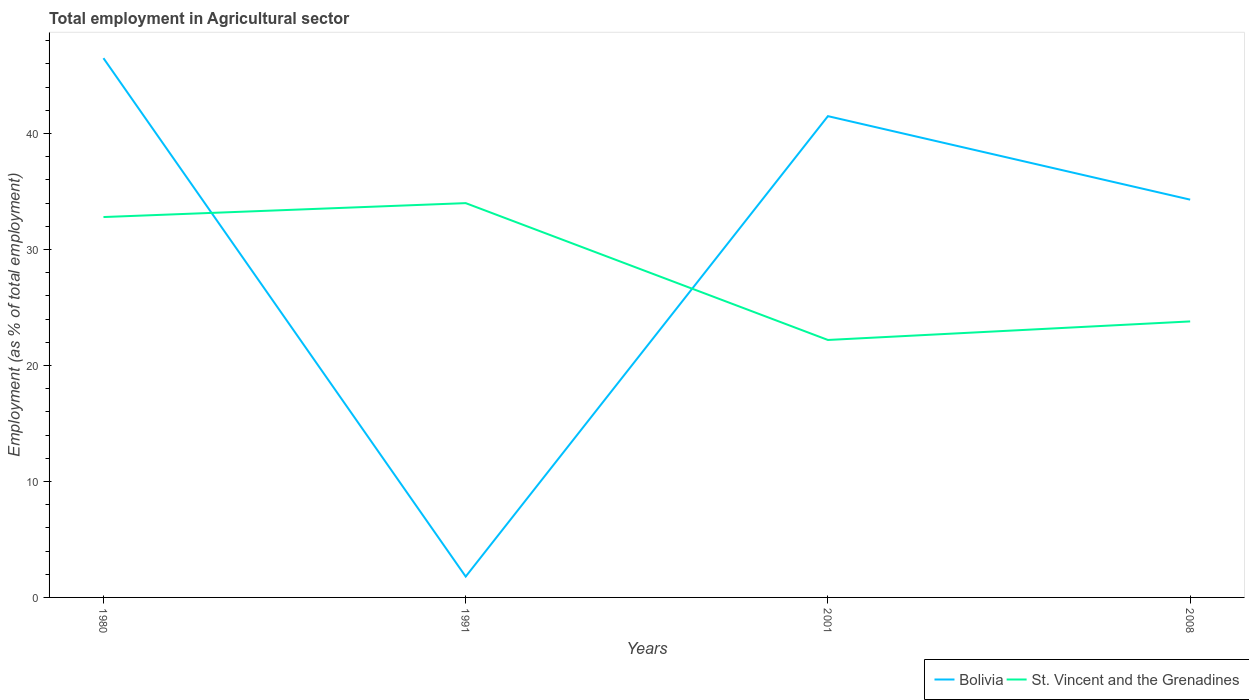How many different coloured lines are there?
Give a very brief answer. 2. Is the number of lines equal to the number of legend labels?
Offer a very short reply. Yes. Across all years, what is the maximum employment in agricultural sector in Bolivia?
Offer a very short reply. 1.8. What is the total employment in agricultural sector in St. Vincent and the Grenadines in the graph?
Make the answer very short. 9. What is the difference between the highest and the second highest employment in agricultural sector in St. Vincent and the Grenadines?
Provide a succinct answer. 11.8. What is the difference between the highest and the lowest employment in agricultural sector in St. Vincent and the Grenadines?
Make the answer very short. 2. How many lines are there?
Give a very brief answer. 2. How many years are there in the graph?
Give a very brief answer. 4. Are the values on the major ticks of Y-axis written in scientific E-notation?
Give a very brief answer. No. Does the graph contain any zero values?
Your response must be concise. No. Does the graph contain grids?
Keep it short and to the point. No. What is the title of the graph?
Offer a very short reply. Total employment in Agricultural sector. Does "Latin America(all income levels)" appear as one of the legend labels in the graph?
Your answer should be very brief. No. What is the label or title of the Y-axis?
Offer a terse response. Employment (as % of total employment). What is the Employment (as % of total employment) of Bolivia in 1980?
Your answer should be very brief. 46.5. What is the Employment (as % of total employment) in St. Vincent and the Grenadines in 1980?
Your answer should be compact. 32.8. What is the Employment (as % of total employment) of Bolivia in 1991?
Ensure brevity in your answer.  1.8. What is the Employment (as % of total employment) in St. Vincent and the Grenadines in 1991?
Provide a short and direct response. 34. What is the Employment (as % of total employment) in Bolivia in 2001?
Provide a succinct answer. 41.5. What is the Employment (as % of total employment) in St. Vincent and the Grenadines in 2001?
Ensure brevity in your answer.  22.2. What is the Employment (as % of total employment) of Bolivia in 2008?
Your answer should be compact. 34.3. What is the Employment (as % of total employment) in St. Vincent and the Grenadines in 2008?
Keep it short and to the point. 23.8. Across all years, what is the maximum Employment (as % of total employment) of Bolivia?
Provide a short and direct response. 46.5. Across all years, what is the maximum Employment (as % of total employment) of St. Vincent and the Grenadines?
Ensure brevity in your answer.  34. Across all years, what is the minimum Employment (as % of total employment) of Bolivia?
Make the answer very short. 1.8. Across all years, what is the minimum Employment (as % of total employment) of St. Vincent and the Grenadines?
Give a very brief answer. 22.2. What is the total Employment (as % of total employment) of Bolivia in the graph?
Your answer should be very brief. 124.1. What is the total Employment (as % of total employment) of St. Vincent and the Grenadines in the graph?
Keep it short and to the point. 112.8. What is the difference between the Employment (as % of total employment) in Bolivia in 1980 and that in 1991?
Offer a very short reply. 44.7. What is the difference between the Employment (as % of total employment) of Bolivia in 1980 and that in 2001?
Offer a very short reply. 5. What is the difference between the Employment (as % of total employment) of St. Vincent and the Grenadines in 1980 and that in 2001?
Your response must be concise. 10.6. What is the difference between the Employment (as % of total employment) in Bolivia in 1991 and that in 2001?
Offer a very short reply. -39.7. What is the difference between the Employment (as % of total employment) of St. Vincent and the Grenadines in 1991 and that in 2001?
Your answer should be very brief. 11.8. What is the difference between the Employment (as % of total employment) in Bolivia in 1991 and that in 2008?
Offer a terse response. -32.5. What is the difference between the Employment (as % of total employment) of St. Vincent and the Grenadines in 1991 and that in 2008?
Give a very brief answer. 10.2. What is the difference between the Employment (as % of total employment) in Bolivia in 2001 and that in 2008?
Your response must be concise. 7.2. What is the difference between the Employment (as % of total employment) in Bolivia in 1980 and the Employment (as % of total employment) in St. Vincent and the Grenadines in 2001?
Give a very brief answer. 24.3. What is the difference between the Employment (as % of total employment) of Bolivia in 1980 and the Employment (as % of total employment) of St. Vincent and the Grenadines in 2008?
Keep it short and to the point. 22.7. What is the difference between the Employment (as % of total employment) of Bolivia in 1991 and the Employment (as % of total employment) of St. Vincent and the Grenadines in 2001?
Provide a succinct answer. -20.4. What is the difference between the Employment (as % of total employment) in Bolivia in 1991 and the Employment (as % of total employment) in St. Vincent and the Grenadines in 2008?
Keep it short and to the point. -22. What is the average Employment (as % of total employment) in Bolivia per year?
Keep it short and to the point. 31.02. What is the average Employment (as % of total employment) in St. Vincent and the Grenadines per year?
Provide a succinct answer. 28.2. In the year 1991, what is the difference between the Employment (as % of total employment) of Bolivia and Employment (as % of total employment) of St. Vincent and the Grenadines?
Your answer should be compact. -32.2. In the year 2001, what is the difference between the Employment (as % of total employment) of Bolivia and Employment (as % of total employment) of St. Vincent and the Grenadines?
Your response must be concise. 19.3. In the year 2008, what is the difference between the Employment (as % of total employment) of Bolivia and Employment (as % of total employment) of St. Vincent and the Grenadines?
Offer a terse response. 10.5. What is the ratio of the Employment (as % of total employment) of Bolivia in 1980 to that in 1991?
Offer a terse response. 25.83. What is the ratio of the Employment (as % of total employment) of St. Vincent and the Grenadines in 1980 to that in 1991?
Your answer should be very brief. 0.96. What is the ratio of the Employment (as % of total employment) of Bolivia in 1980 to that in 2001?
Keep it short and to the point. 1.12. What is the ratio of the Employment (as % of total employment) of St. Vincent and the Grenadines in 1980 to that in 2001?
Your answer should be very brief. 1.48. What is the ratio of the Employment (as % of total employment) of Bolivia in 1980 to that in 2008?
Keep it short and to the point. 1.36. What is the ratio of the Employment (as % of total employment) in St. Vincent and the Grenadines in 1980 to that in 2008?
Give a very brief answer. 1.38. What is the ratio of the Employment (as % of total employment) of Bolivia in 1991 to that in 2001?
Provide a short and direct response. 0.04. What is the ratio of the Employment (as % of total employment) of St. Vincent and the Grenadines in 1991 to that in 2001?
Offer a terse response. 1.53. What is the ratio of the Employment (as % of total employment) of Bolivia in 1991 to that in 2008?
Your answer should be very brief. 0.05. What is the ratio of the Employment (as % of total employment) in St. Vincent and the Grenadines in 1991 to that in 2008?
Offer a terse response. 1.43. What is the ratio of the Employment (as % of total employment) of Bolivia in 2001 to that in 2008?
Give a very brief answer. 1.21. What is the ratio of the Employment (as % of total employment) of St. Vincent and the Grenadines in 2001 to that in 2008?
Offer a very short reply. 0.93. What is the difference between the highest and the second highest Employment (as % of total employment) in Bolivia?
Make the answer very short. 5. What is the difference between the highest and the second highest Employment (as % of total employment) of St. Vincent and the Grenadines?
Offer a terse response. 1.2. What is the difference between the highest and the lowest Employment (as % of total employment) in Bolivia?
Your answer should be very brief. 44.7. What is the difference between the highest and the lowest Employment (as % of total employment) in St. Vincent and the Grenadines?
Provide a succinct answer. 11.8. 